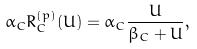<formula> <loc_0><loc_0><loc_500><loc_500>\alpha _ { C } R _ { C } ^ { ( p ) } ( U ) = \alpha _ { C } \frac { U } { \beta _ { C } + U } ,</formula> 